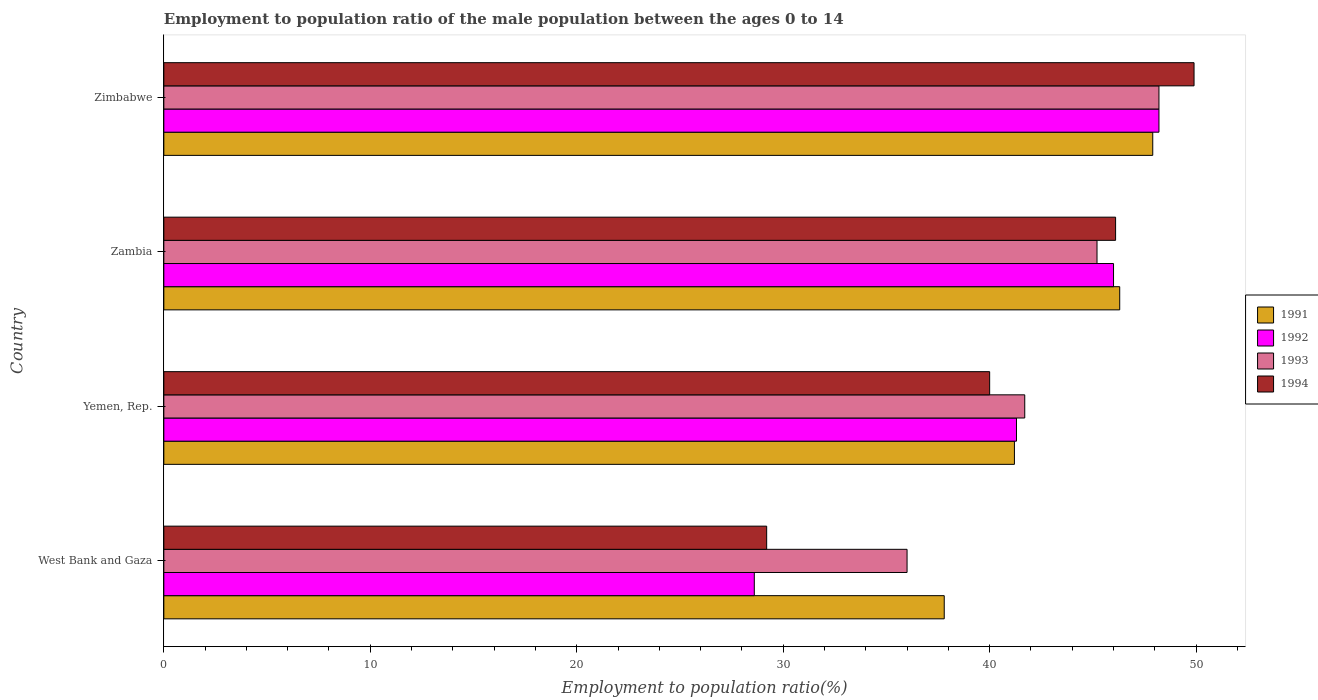How many different coloured bars are there?
Make the answer very short. 4. How many groups of bars are there?
Provide a short and direct response. 4. Are the number of bars per tick equal to the number of legend labels?
Ensure brevity in your answer.  Yes. Are the number of bars on each tick of the Y-axis equal?
Offer a terse response. Yes. What is the label of the 1st group of bars from the top?
Provide a succinct answer. Zimbabwe. What is the employment to population ratio in 1994 in Zimbabwe?
Give a very brief answer. 49.9. Across all countries, what is the maximum employment to population ratio in 1994?
Your answer should be compact. 49.9. Across all countries, what is the minimum employment to population ratio in 1994?
Your response must be concise. 29.2. In which country was the employment to population ratio in 1993 maximum?
Your response must be concise. Zimbabwe. In which country was the employment to population ratio in 1992 minimum?
Keep it short and to the point. West Bank and Gaza. What is the total employment to population ratio in 1992 in the graph?
Make the answer very short. 164.1. What is the difference between the employment to population ratio in 1991 in Yemen, Rep. and that in Zimbabwe?
Offer a very short reply. -6.7. What is the difference between the employment to population ratio in 1991 in Zimbabwe and the employment to population ratio in 1994 in Zambia?
Keep it short and to the point. 1.8. What is the average employment to population ratio in 1993 per country?
Your answer should be very brief. 42.78. What is the difference between the employment to population ratio in 1991 and employment to population ratio in 1994 in Zimbabwe?
Ensure brevity in your answer.  -2. What is the ratio of the employment to population ratio in 1994 in Zambia to that in Zimbabwe?
Your answer should be compact. 0.92. What is the difference between the highest and the second highest employment to population ratio in 1994?
Make the answer very short. 3.8. What is the difference between the highest and the lowest employment to population ratio in 1993?
Ensure brevity in your answer.  12.2. Is the sum of the employment to population ratio in 1992 in Zambia and Zimbabwe greater than the maximum employment to population ratio in 1991 across all countries?
Offer a very short reply. Yes. What does the 4th bar from the top in Zimbabwe represents?
Ensure brevity in your answer.  1991. What does the 1st bar from the bottom in Yemen, Rep. represents?
Offer a terse response. 1991. Is it the case that in every country, the sum of the employment to population ratio in 1992 and employment to population ratio in 1991 is greater than the employment to population ratio in 1994?
Ensure brevity in your answer.  Yes. How many bars are there?
Keep it short and to the point. 16. What is the difference between two consecutive major ticks on the X-axis?
Give a very brief answer. 10. Are the values on the major ticks of X-axis written in scientific E-notation?
Your response must be concise. No. Does the graph contain any zero values?
Provide a short and direct response. No. Does the graph contain grids?
Ensure brevity in your answer.  No. How are the legend labels stacked?
Ensure brevity in your answer.  Vertical. What is the title of the graph?
Provide a succinct answer. Employment to population ratio of the male population between the ages 0 to 14. What is the label or title of the Y-axis?
Keep it short and to the point. Country. What is the Employment to population ratio(%) in 1991 in West Bank and Gaza?
Offer a terse response. 37.8. What is the Employment to population ratio(%) of 1992 in West Bank and Gaza?
Give a very brief answer. 28.6. What is the Employment to population ratio(%) in 1994 in West Bank and Gaza?
Your answer should be compact. 29.2. What is the Employment to population ratio(%) of 1991 in Yemen, Rep.?
Ensure brevity in your answer.  41.2. What is the Employment to population ratio(%) of 1992 in Yemen, Rep.?
Your answer should be very brief. 41.3. What is the Employment to population ratio(%) of 1993 in Yemen, Rep.?
Provide a succinct answer. 41.7. What is the Employment to population ratio(%) in 1994 in Yemen, Rep.?
Keep it short and to the point. 40. What is the Employment to population ratio(%) in 1991 in Zambia?
Provide a succinct answer. 46.3. What is the Employment to population ratio(%) in 1993 in Zambia?
Provide a short and direct response. 45.2. What is the Employment to population ratio(%) in 1994 in Zambia?
Ensure brevity in your answer.  46.1. What is the Employment to population ratio(%) in 1991 in Zimbabwe?
Ensure brevity in your answer.  47.9. What is the Employment to population ratio(%) of 1992 in Zimbabwe?
Offer a very short reply. 48.2. What is the Employment to population ratio(%) in 1993 in Zimbabwe?
Keep it short and to the point. 48.2. What is the Employment to population ratio(%) in 1994 in Zimbabwe?
Your answer should be very brief. 49.9. Across all countries, what is the maximum Employment to population ratio(%) in 1991?
Make the answer very short. 47.9. Across all countries, what is the maximum Employment to population ratio(%) of 1992?
Ensure brevity in your answer.  48.2. Across all countries, what is the maximum Employment to population ratio(%) of 1993?
Your answer should be very brief. 48.2. Across all countries, what is the maximum Employment to population ratio(%) of 1994?
Provide a short and direct response. 49.9. Across all countries, what is the minimum Employment to population ratio(%) in 1991?
Keep it short and to the point. 37.8. Across all countries, what is the minimum Employment to population ratio(%) in 1992?
Your answer should be compact. 28.6. Across all countries, what is the minimum Employment to population ratio(%) of 1994?
Your answer should be compact. 29.2. What is the total Employment to population ratio(%) in 1991 in the graph?
Your response must be concise. 173.2. What is the total Employment to population ratio(%) in 1992 in the graph?
Provide a succinct answer. 164.1. What is the total Employment to population ratio(%) in 1993 in the graph?
Provide a succinct answer. 171.1. What is the total Employment to population ratio(%) of 1994 in the graph?
Your response must be concise. 165.2. What is the difference between the Employment to population ratio(%) of 1992 in West Bank and Gaza and that in Yemen, Rep.?
Give a very brief answer. -12.7. What is the difference between the Employment to population ratio(%) of 1993 in West Bank and Gaza and that in Yemen, Rep.?
Offer a very short reply. -5.7. What is the difference between the Employment to population ratio(%) of 1991 in West Bank and Gaza and that in Zambia?
Your answer should be very brief. -8.5. What is the difference between the Employment to population ratio(%) of 1992 in West Bank and Gaza and that in Zambia?
Offer a very short reply. -17.4. What is the difference between the Employment to population ratio(%) in 1994 in West Bank and Gaza and that in Zambia?
Give a very brief answer. -16.9. What is the difference between the Employment to population ratio(%) of 1991 in West Bank and Gaza and that in Zimbabwe?
Make the answer very short. -10.1. What is the difference between the Employment to population ratio(%) of 1992 in West Bank and Gaza and that in Zimbabwe?
Your answer should be very brief. -19.6. What is the difference between the Employment to population ratio(%) of 1994 in West Bank and Gaza and that in Zimbabwe?
Keep it short and to the point. -20.7. What is the difference between the Employment to population ratio(%) of 1992 in Yemen, Rep. and that in Zambia?
Offer a very short reply. -4.7. What is the difference between the Employment to population ratio(%) in 1994 in Yemen, Rep. and that in Zambia?
Keep it short and to the point. -6.1. What is the difference between the Employment to population ratio(%) in 1991 in Yemen, Rep. and that in Zimbabwe?
Offer a very short reply. -6.7. What is the difference between the Employment to population ratio(%) in 1992 in Yemen, Rep. and that in Zimbabwe?
Provide a short and direct response. -6.9. What is the difference between the Employment to population ratio(%) of 1994 in Yemen, Rep. and that in Zimbabwe?
Your response must be concise. -9.9. What is the difference between the Employment to population ratio(%) of 1992 in Zambia and that in Zimbabwe?
Keep it short and to the point. -2.2. What is the difference between the Employment to population ratio(%) of 1991 in West Bank and Gaza and the Employment to population ratio(%) of 1992 in Yemen, Rep.?
Offer a terse response. -3.5. What is the difference between the Employment to population ratio(%) of 1991 in West Bank and Gaza and the Employment to population ratio(%) of 1994 in Yemen, Rep.?
Offer a terse response. -2.2. What is the difference between the Employment to population ratio(%) of 1992 in West Bank and Gaza and the Employment to population ratio(%) of 1993 in Yemen, Rep.?
Give a very brief answer. -13.1. What is the difference between the Employment to population ratio(%) of 1993 in West Bank and Gaza and the Employment to population ratio(%) of 1994 in Yemen, Rep.?
Your answer should be compact. -4. What is the difference between the Employment to population ratio(%) of 1991 in West Bank and Gaza and the Employment to population ratio(%) of 1992 in Zambia?
Your answer should be compact. -8.2. What is the difference between the Employment to population ratio(%) in 1991 in West Bank and Gaza and the Employment to population ratio(%) in 1994 in Zambia?
Make the answer very short. -8.3. What is the difference between the Employment to population ratio(%) of 1992 in West Bank and Gaza and the Employment to population ratio(%) of 1993 in Zambia?
Keep it short and to the point. -16.6. What is the difference between the Employment to population ratio(%) in 1992 in West Bank and Gaza and the Employment to population ratio(%) in 1994 in Zambia?
Give a very brief answer. -17.5. What is the difference between the Employment to population ratio(%) in 1991 in West Bank and Gaza and the Employment to population ratio(%) in 1992 in Zimbabwe?
Provide a short and direct response. -10.4. What is the difference between the Employment to population ratio(%) in 1991 in West Bank and Gaza and the Employment to population ratio(%) in 1994 in Zimbabwe?
Ensure brevity in your answer.  -12.1. What is the difference between the Employment to population ratio(%) in 1992 in West Bank and Gaza and the Employment to population ratio(%) in 1993 in Zimbabwe?
Your answer should be very brief. -19.6. What is the difference between the Employment to population ratio(%) of 1992 in West Bank and Gaza and the Employment to population ratio(%) of 1994 in Zimbabwe?
Offer a very short reply. -21.3. What is the difference between the Employment to population ratio(%) in 1993 in West Bank and Gaza and the Employment to population ratio(%) in 1994 in Zimbabwe?
Provide a succinct answer. -13.9. What is the difference between the Employment to population ratio(%) of 1991 in Yemen, Rep. and the Employment to population ratio(%) of 1992 in Zambia?
Offer a terse response. -4.8. What is the difference between the Employment to population ratio(%) of 1991 in Yemen, Rep. and the Employment to population ratio(%) of 1994 in Zambia?
Give a very brief answer. -4.9. What is the difference between the Employment to population ratio(%) of 1992 in Yemen, Rep. and the Employment to population ratio(%) of 1993 in Zambia?
Ensure brevity in your answer.  -3.9. What is the difference between the Employment to population ratio(%) of 1992 in Yemen, Rep. and the Employment to population ratio(%) of 1994 in Zambia?
Provide a succinct answer. -4.8. What is the difference between the Employment to population ratio(%) in 1991 in Yemen, Rep. and the Employment to population ratio(%) in 1992 in Zimbabwe?
Ensure brevity in your answer.  -7. What is the difference between the Employment to population ratio(%) of 1991 in Yemen, Rep. and the Employment to population ratio(%) of 1994 in Zimbabwe?
Give a very brief answer. -8.7. What is the difference between the Employment to population ratio(%) of 1992 in Yemen, Rep. and the Employment to population ratio(%) of 1993 in Zimbabwe?
Offer a terse response. -6.9. What is the difference between the Employment to population ratio(%) of 1992 in Yemen, Rep. and the Employment to population ratio(%) of 1994 in Zimbabwe?
Ensure brevity in your answer.  -8.6. What is the difference between the Employment to population ratio(%) of 1991 in Zambia and the Employment to population ratio(%) of 1992 in Zimbabwe?
Provide a succinct answer. -1.9. What is the difference between the Employment to population ratio(%) of 1992 in Zambia and the Employment to population ratio(%) of 1993 in Zimbabwe?
Your answer should be very brief. -2.2. What is the difference between the Employment to population ratio(%) in 1992 in Zambia and the Employment to population ratio(%) in 1994 in Zimbabwe?
Your answer should be compact. -3.9. What is the average Employment to population ratio(%) of 1991 per country?
Ensure brevity in your answer.  43.3. What is the average Employment to population ratio(%) in 1992 per country?
Offer a very short reply. 41.02. What is the average Employment to population ratio(%) in 1993 per country?
Your answer should be very brief. 42.77. What is the average Employment to population ratio(%) of 1994 per country?
Offer a terse response. 41.3. What is the difference between the Employment to population ratio(%) in 1991 and Employment to population ratio(%) in 1994 in West Bank and Gaza?
Your answer should be very brief. 8.6. What is the difference between the Employment to population ratio(%) of 1992 and Employment to population ratio(%) of 1993 in West Bank and Gaza?
Provide a succinct answer. -7.4. What is the difference between the Employment to population ratio(%) of 1992 and Employment to population ratio(%) of 1994 in West Bank and Gaza?
Your answer should be very brief. -0.6. What is the difference between the Employment to population ratio(%) of 1991 and Employment to population ratio(%) of 1993 in Yemen, Rep.?
Ensure brevity in your answer.  -0.5. What is the difference between the Employment to population ratio(%) in 1991 and Employment to population ratio(%) in 1994 in Yemen, Rep.?
Your answer should be very brief. 1.2. What is the difference between the Employment to population ratio(%) of 1992 and Employment to population ratio(%) of 1993 in Yemen, Rep.?
Ensure brevity in your answer.  -0.4. What is the difference between the Employment to population ratio(%) of 1991 and Employment to population ratio(%) of 1992 in Zambia?
Give a very brief answer. 0.3. What is the difference between the Employment to population ratio(%) in 1991 and Employment to population ratio(%) in 1993 in Zambia?
Give a very brief answer. 1.1. What is the difference between the Employment to population ratio(%) of 1992 and Employment to population ratio(%) of 1994 in Zambia?
Offer a terse response. -0.1. What is the difference between the Employment to population ratio(%) of 1993 and Employment to population ratio(%) of 1994 in Zambia?
Your response must be concise. -0.9. What is the difference between the Employment to population ratio(%) in 1991 and Employment to population ratio(%) in 1992 in Zimbabwe?
Provide a succinct answer. -0.3. What is the difference between the Employment to population ratio(%) of 1992 and Employment to population ratio(%) of 1993 in Zimbabwe?
Your answer should be compact. 0. What is the difference between the Employment to population ratio(%) of 1992 and Employment to population ratio(%) of 1994 in Zimbabwe?
Keep it short and to the point. -1.7. What is the ratio of the Employment to population ratio(%) of 1991 in West Bank and Gaza to that in Yemen, Rep.?
Keep it short and to the point. 0.92. What is the ratio of the Employment to population ratio(%) of 1992 in West Bank and Gaza to that in Yemen, Rep.?
Make the answer very short. 0.69. What is the ratio of the Employment to population ratio(%) in 1993 in West Bank and Gaza to that in Yemen, Rep.?
Provide a succinct answer. 0.86. What is the ratio of the Employment to population ratio(%) of 1994 in West Bank and Gaza to that in Yemen, Rep.?
Keep it short and to the point. 0.73. What is the ratio of the Employment to population ratio(%) in 1991 in West Bank and Gaza to that in Zambia?
Offer a very short reply. 0.82. What is the ratio of the Employment to population ratio(%) of 1992 in West Bank and Gaza to that in Zambia?
Provide a succinct answer. 0.62. What is the ratio of the Employment to population ratio(%) in 1993 in West Bank and Gaza to that in Zambia?
Your answer should be very brief. 0.8. What is the ratio of the Employment to population ratio(%) of 1994 in West Bank and Gaza to that in Zambia?
Offer a terse response. 0.63. What is the ratio of the Employment to population ratio(%) in 1991 in West Bank and Gaza to that in Zimbabwe?
Your response must be concise. 0.79. What is the ratio of the Employment to population ratio(%) in 1992 in West Bank and Gaza to that in Zimbabwe?
Your response must be concise. 0.59. What is the ratio of the Employment to population ratio(%) in 1993 in West Bank and Gaza to that in Zimbabwe?
Your answer should be compact. 0.75. What is the ratio of the Employment to population ratio(%) in 1994 in West Bank and Gaza to that in Zimbabwe?
Offer a very short reply. 0.59. What is the ratio of the Employment to population ratio(%) of 1991 in Yemen, Rep. to that in Zambia?
Your answer should be very brief. 0.89. What is the ratio of the Employment to population ratio(%) of 1992 in Yemen, Rep. to that in Zambia?
Your answer should be compact. 0.9. What is the ratio of the Employment to population ratio(%) of 1993 in Yemen, Rep. to that in Zambia?
Keep it short and to the point. 0.92. What is the ratio of the Employment to population ratio(%) of 1994 in Yemen, Rep. to that in Zambia?
Your answer should be very brief. 0.87. What is the ratio of the Employment to population ratio(%) in 1991 in Yemen, Rep. to that in Zimbabwe?
Provide a succinct answer. 0.86. What is the ratio of the Employment to population ratio(%) of 1992 in Yemen, Rep. to that in Zimbabwe?
Provide a succinct answer. 0.86. What is the ratio of the Employment to population ratio(%) of 1993 in Yemen, Rep. to that in Zimbabwe?
Your answer should be very brief. 0.87. What is the ratio of the Employment to population ratio(%) in 1994 in Yemen, Rep. to that in Zimbabwe?
Offer a very short reply. 0.8. What is the ratio of the Employment to population ratio(%) in 1991 in Zambia to that in Zimbabwe?
Offer a very short reply. 0.97. What is the ratio of the Employment to population ratio(%) of 1992 in Zambia to that in Zimbabwe?
Your answer should be compact. 0.95. What is the ratio of the Employment to population ratio(%) of 1993 in Zambia to that in Zimbabwe?
Offer a very short reply. 0.94. What is the ratio of the Employment to population ratio(%) of 1994 in Zambia to that in Zimbabwe?
Your answer should be compact. 0.92. What is the difference between the highest and the second highest Employment to population ratio(%) in 1991?
Make the answer very short. 1.6. What is the difference between the highest and the second highest Employment to population ratio(%) in 1992?
Ensure brevity in your answer.  2.2. What is the difference between the highest and the second highest Employment to population ratio(%) in 1994?
Provide a succinct answer. 3.8. What is the difference between the highest and the lowest Employment to population ratio(%) in 1992?
Provide a succinct answer. 19.6. What is the difference between the highest and the lowest Employment to population ratio(%) in 1993?
Give a very brief answer. 12.2. What is the difference between the highest and the lowest Employment to population ratio(%) of 1994?
Provide a succinct answer. 20.7. 